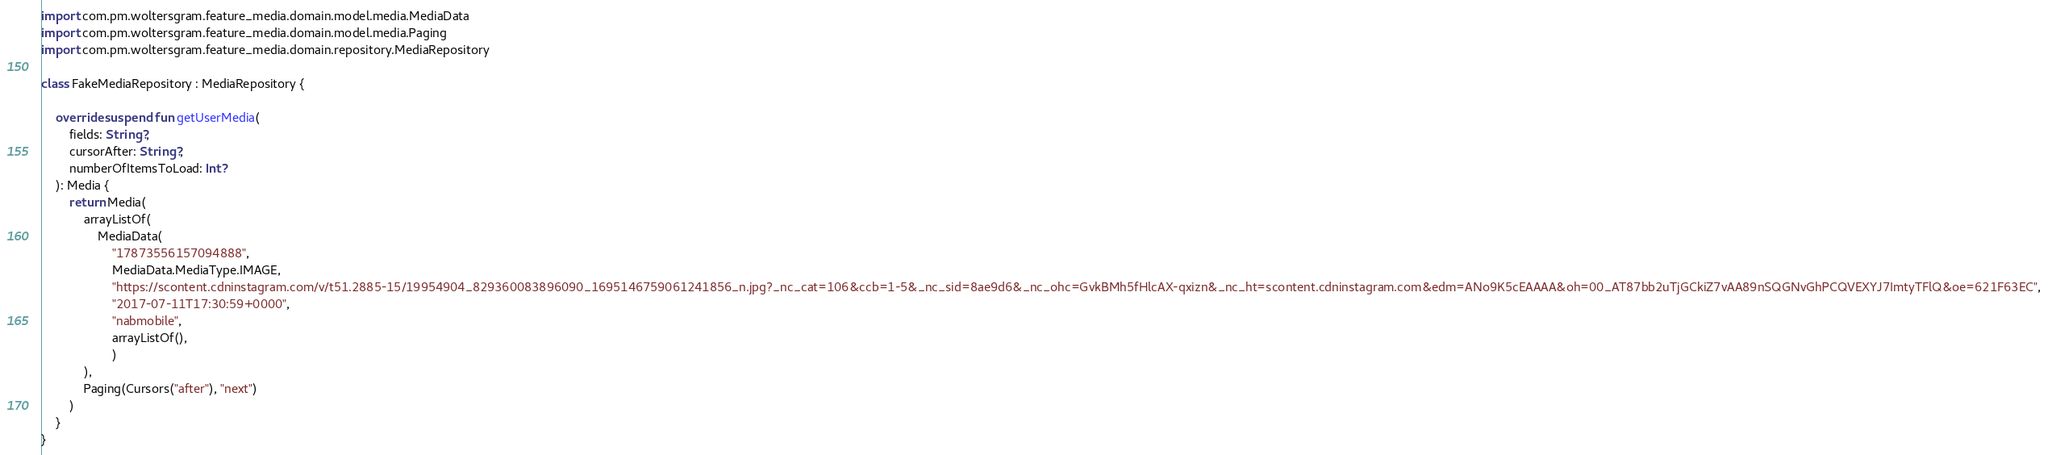Convert code to text. <code><loc_0><loc_0><loc_500><loc_500><_Kotlin_>import com.pm.woltersgram.feature_media.domain.model.media.MediaData
import com.pm.woltersgram.feature_media.domain.model.media.Paging
import com.pm.woltersgram.feature_media.domain.repository.MediaRepository

class FakeMediaRepository : MediaRepository {

    override suspend fun getUserMedia(
        fields: String?,
        cursorAfter: String?,
        numberOfItemsToLoad: Int?
    ): Media {
        return Media(
            arrayListOf(
                MediaData(
                    "17873556157094888",
                    MediaData.MediaType.IMAGE,
                    "https://scontent.cdninstagram.com/v/t51.2885-15/19954904_829360083896090_1695146759061241856_n.jpg?_nc_cat=106&ccb=1-5&_nc_sid=8ae9d6&_nc_ohc=GvkBMh5fHlcAX-qxizn&_nc_ht=scontent.cdninstagram.com&edm=ANo9K5cEAAAA&oh=00_AT87bb2uTjGCkiZ7vAA89nSQGNvGhPCQVEXYJ7ImtyTFlQ&oe=621F63EC",
                    "2017-07-11T17:30:59+0000",
                    "nabmobile",
                    arrayListOf(),
                    )
            ),
            Paging(Cursors("after"), "next")
        )
    }
}</code> 